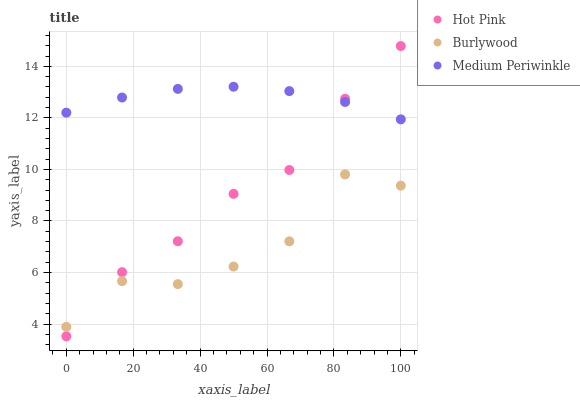Does Burlywood have the minimum area under the curve?
Answer yes or no. Yes. Does Medium Periwinkle have the maximum area under the curve?
Answer yes or no. Yes. Does Hot Pink have the minimum area under the curve?
Answer yes or no. No. Does Hot Pink have the maximum area under the curve?
Answer yes or no. No. Is Medium Periwinkle the smoothest?
Answer yes or no. Yes. Is Burlywood the roughest?
Answer yes or no. Yes. Is Hot Pink the smoothest?
Answer yes or no. No. Is Hot Pink the roughest?
Answer yes or no. No. Does Hot Pink have the lowest value?
Answer yes or no. Yes. Does Medium Periwinkle have the lowest value?
Answer yes or no. No. Does Hot Pink have the highest value?
Answer yes or no. Yes. Does Medium Periwinkle have the highest value?
Answer yes or no. No. Is Burlywood less than Medium Periwinkle?
Answer yes or no. Yes. Is Medium Periwinkle greater than Burlywood?
Answer yes or no. Yes. Does Burlywood intersect Hot Pink?
Answer yes or no. Yes. Is Burlywood less than Hot Pink?
Answer yes or no. No. Is Burlywood greater than Hot Pink?
Answer yes or no. No. Does Burlywood intersect Medium Periwinkle?
Answer yes or no. No. 